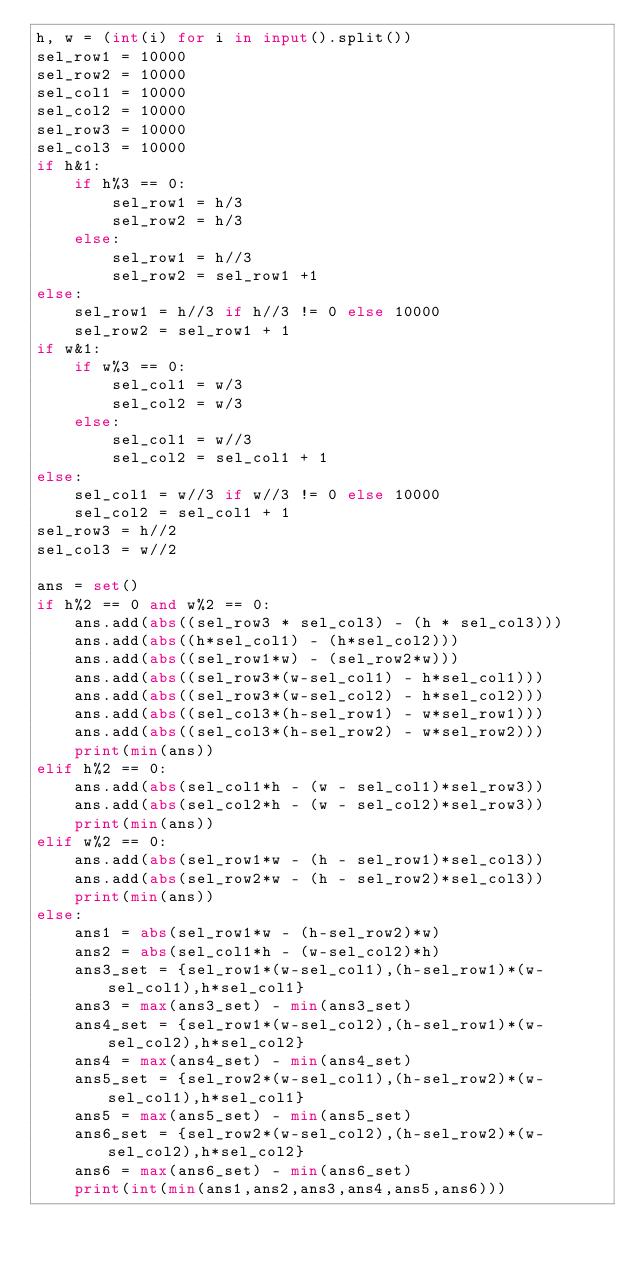<code> <loc_0><loc_0><loc_500><loc_500><_Python_>h, w = (int(i) for i in input().split())
sel_row1 = 10000
sel_row2 = 10000
sel_col1 = 10000
sel_col2 = 10000
sel_row3 = 10000
sel_col3 = 10000
if h&1:
    if h%3 == 0:
        sel_row1 = h/3
        sel_row2 = h/3
    else:
        sel_row1 = h//3
        sel_row2 = sel_row1 +1
else:
    sel_row1 = h//3 if h//3 != 0 else 10000
    sel_row2 = sel_row1 + 1
if w&1:
    if w%3 == 0:
        sel_col1 = w/3
        sel_col2 = w/3
    else:
        sel_col1 = w//3
        sel_col2 = sel_col1 + 1
else:
    sel_col1 = w//3 if w//3 != 0 else 10000
    sel_col2 = sel_col1 + 1
sel_row3 = h//2
sel_col3 = w//2

ans = set()
if h%2 == 0 and w%2 == 0:
    ans.add(abs((sel_row3 * sel_col3) - (h * sel_col3)))
    ans.add(abs((h*sel_col1) - (h*sel_col2)))
    ans.add(abs((sel_row1*w) - (sel_row2*w))) 
    ans.add(abs((sel_row3*(w-sel_col1) - h*sel_col1)))
    ans.add(abs((sel_row3*(w-sel_col2) - h*sel_col2)))
    ans.add(abs((sel_col3*(h-sel_row1) - w*sel_row1)))
    ans.add(abs((sel_col3*(h-sel_row2) - w*sel_row2)))
    print(min(ans))
elif h%2 == 0:
    ans.add(abs(sel_col1*h - (w - sel_col1)*sel_row3))
    ans.add(abs(sel_col2*h - (w - sel_col2)*sel_row3))
    print(min(ans))
elif w%2 == 0:
    ans.add(abs(sel_row1*w - (h - sel_row1)*sel_col3))
    ans.add(abs(sel_row2*w - (h - sel_row2)*sel_col3))
    print(min(ans))
else:
    ans1 = abs(sel_row1*w - (h-sel_row2)*w)
    ans2 = abs(sel_col1*h - (w-sel_col2)*h)
    ans3_set = {sel_row1*(w-sel_col1),(h-sel_row1)*(w-sel_col1),h*sel_col1}
    ans3 = max(ans3_set) - min(ans3_set)
    ans4_set = {sel_row1*(w-sel_col2),(h-sel_row1)*(w-sel_col2),h*sel_col2}
    ans4 = max(ans4_set) - min(ans4_set)
    ans5_set = {sel_row2*(w-sel_col1),(h-sel_row2)*(w-sel_col1),h*sel_col1}
    ans5 = max(ans5_set) - min(ans5_set)
    ans6_set = {sel_row2*(w-sel_col2),(h-sel_row2)*(w-sel_col2),h*sel_col2}
    ans6 = max(ans6_set) - min(ans6_set)
    print(int(min(ans1,ans2,ans3,ans4,ans5,ans6)))</code> 